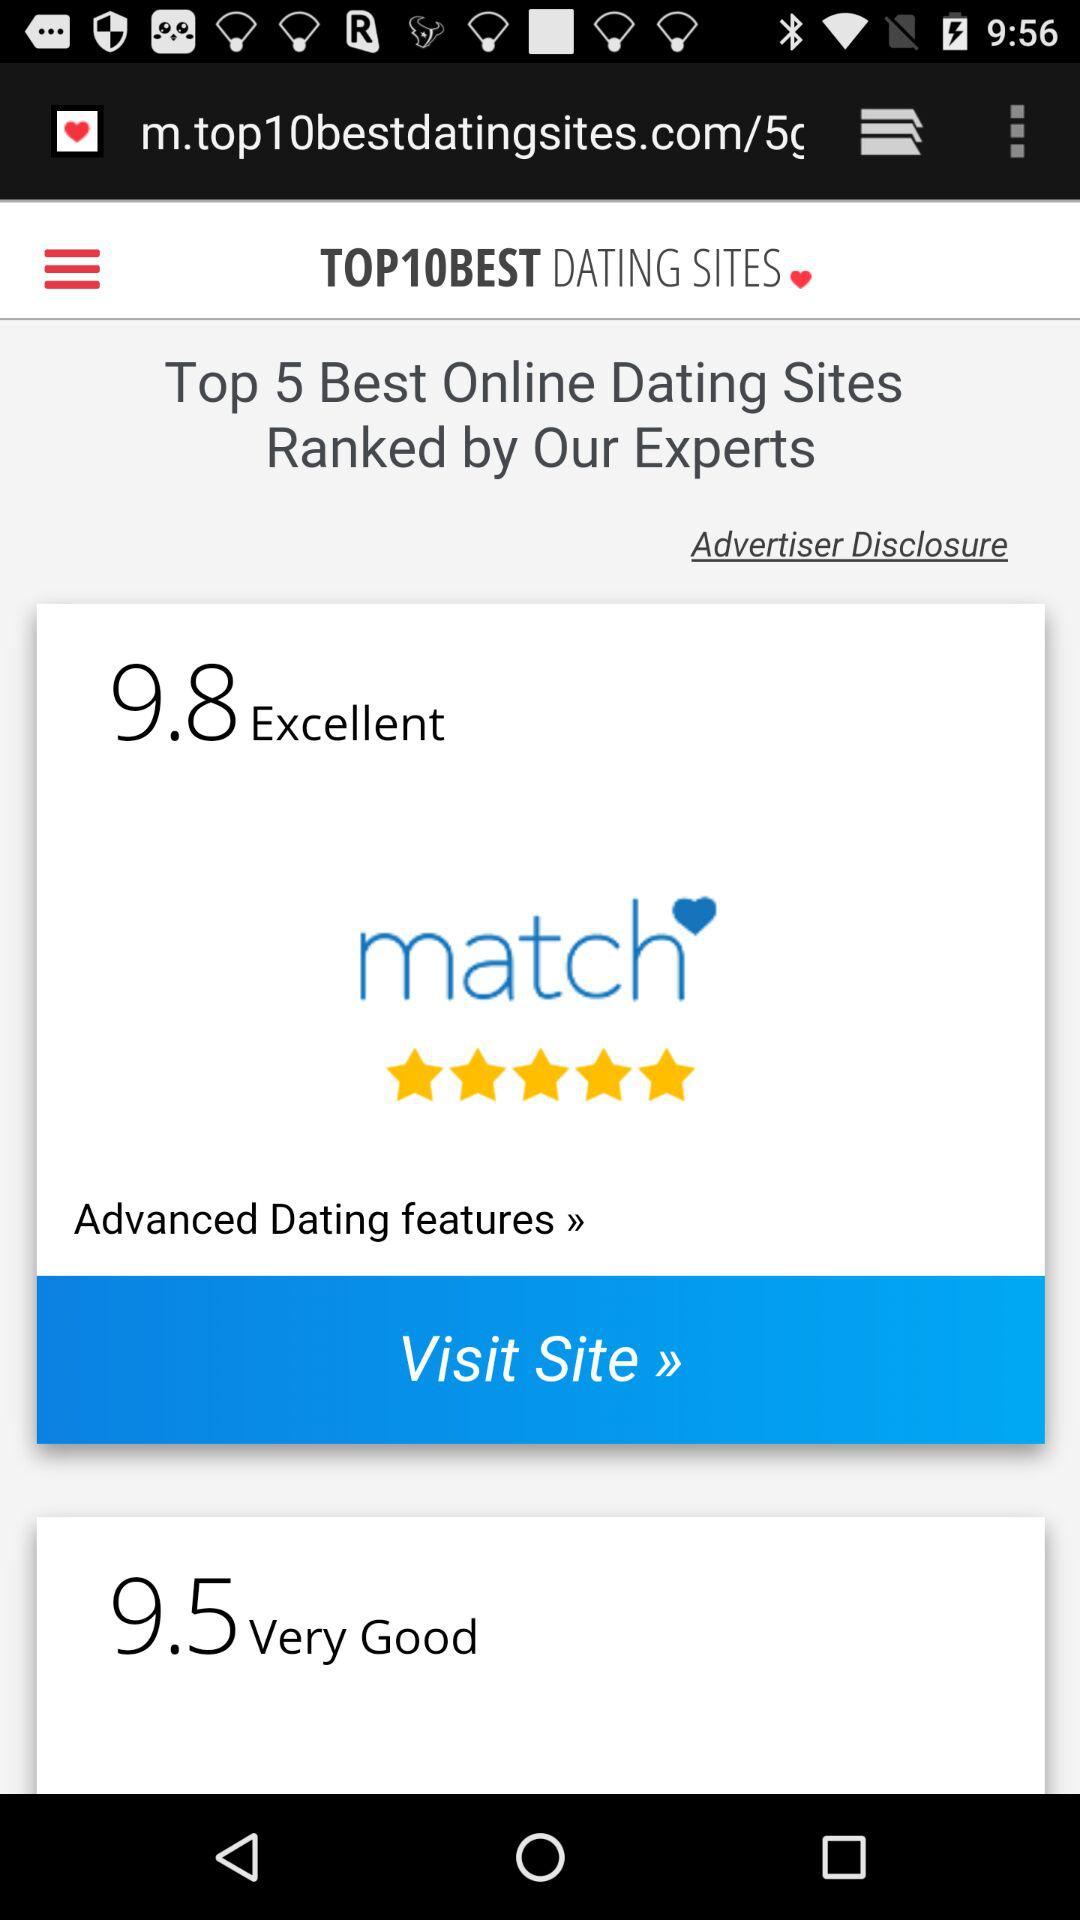What is the rating for "Very Good"? The rating is 9.5. 